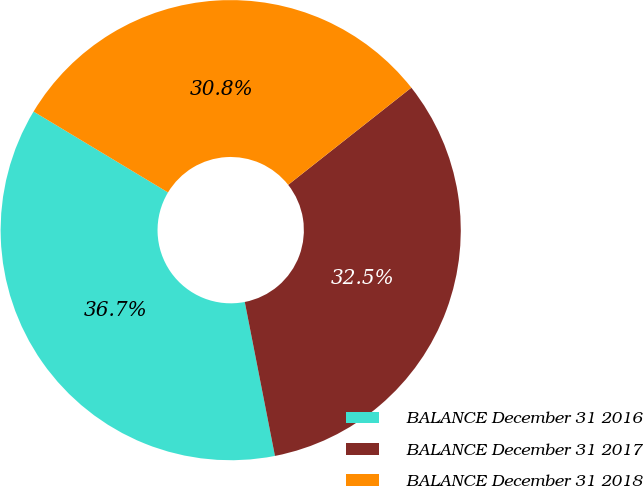Convert chart to OTSL. <chart><loc_0><loc_0><loc_500><loc_500><pie_chart><fcel>BALANCE December 31 2016<fcel>BALANCE December 31 2017<fcel>BALANCE December 31 2018<nl><fcel>36.7%<fcel>32.55%<fcel>30.75%<nl></chart> 